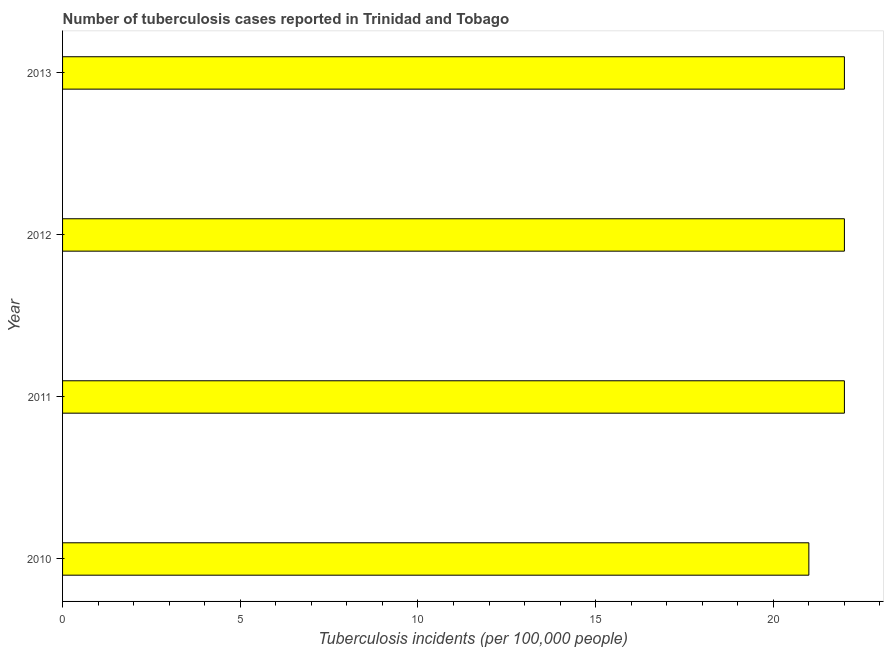What is the title of the graph?
Ensure brevity in your answer.  Number of tuberculosis cases reported in Trinidad and Tobago. What is the label or title of the X-axis?
Give a very brief answer. Tuberculosis incidents (per 100,0 people). What is the number of tuberculosis incidents in 2012?
Your answer should be compact. 22. Across all years, what is the minimum number of tuberculosis incidents?
Provide a short and direct response. 21. In which year was the number of tuberculosis incidents maximum?
Provide a short and direct response. 2011. Do a majority of the years between 2011 and 2012 (inclusive) have number of tuberculosis incidents greater than 1 ?
Provide a succinct answer. Yes. Is the number of tuberculosis incidents in 2010 less than that in 2013?
Provide a succinct answer. Yes. Is the difference between the number of tuberculosis incidents in 2012 and 2013 greater than the difference between any two years?
Provide a short and direct response. No. What is the difference between the highest and the second highest number of tuberculosis incidents?
Provide a succinct answer. 0. Is the sum of the number of tuberculosis incidents in 2012 and 2013 greater than the maximum number of tuberculosis incidents across all years?
Provide a succinct answer. Yes. What is the difference between the highest and the lowest number of tuberculosis incidents?
Provide a short and direct response. 1. In how many years, is the number of tuberculosis incidents greater than the average number of tuberculosis incidents taken over all years?
Keep it short and to the point. 3. What is the difference between two consecutive major ticks on the X-axis?
Your answer should be very brief. 5. What is the Tuberculosis incidents (per 100,000 people) of 2011?
Ensure brevity in your answer.  22. What is the Tuberculosis incidents (per 100,000 people) of 2012?
Your response must be concise. 22. What is the difference between the Tuberculosis incidents (per 100,000 people) in 2010 and 2012?
Give a very brief answer. -1. What is the difference between the Tuberculosis incidents (per 100,000 people) in 2010 and 2013?
Keep it short and to the point. -1. What is the difference between the Tuberculosis incidents (per 100,000 people) in 2011 and 2012?
Make the answer very short. 0. What is the difference between the Tuberculosis incidents (per 100,000 people) in 2011 and 2013?
Offer a very short reply. 0. What is the difference between the Tuberculosis incidents (per 100,000 people) in 2012 and 2013?
Give a very brief answer. 0. What is the ratio of the Tuberculosis incidents (per 100,000 people) in 2010 to that in 2011?
Give a very brief answer. 0.95. What is the ratio of the Tuberculosis incidents (per 100,000 people) in 2010 to that in 2012?
Your response must be concise. 0.95. What is the ratio of the Tuberculosis incidents (per 100,000 people) in 2010 to that in 2013?
Provide a short and direct response. 0.95. What is the ratio of the Tuberculosis incidents (per 100,000 people) in 2011 to that in 2012?
Provide a succinct answer. 1. What is the ratio of the Tuberculosis incidents (per 100,000 people) in 2011 to that in 2013?
Offer a terse response. 1. What is the ratio of the Tuberculosis incidents (per 100,000 people) in 2012 to that in 2013?
Keep it short and to the point. 1. 